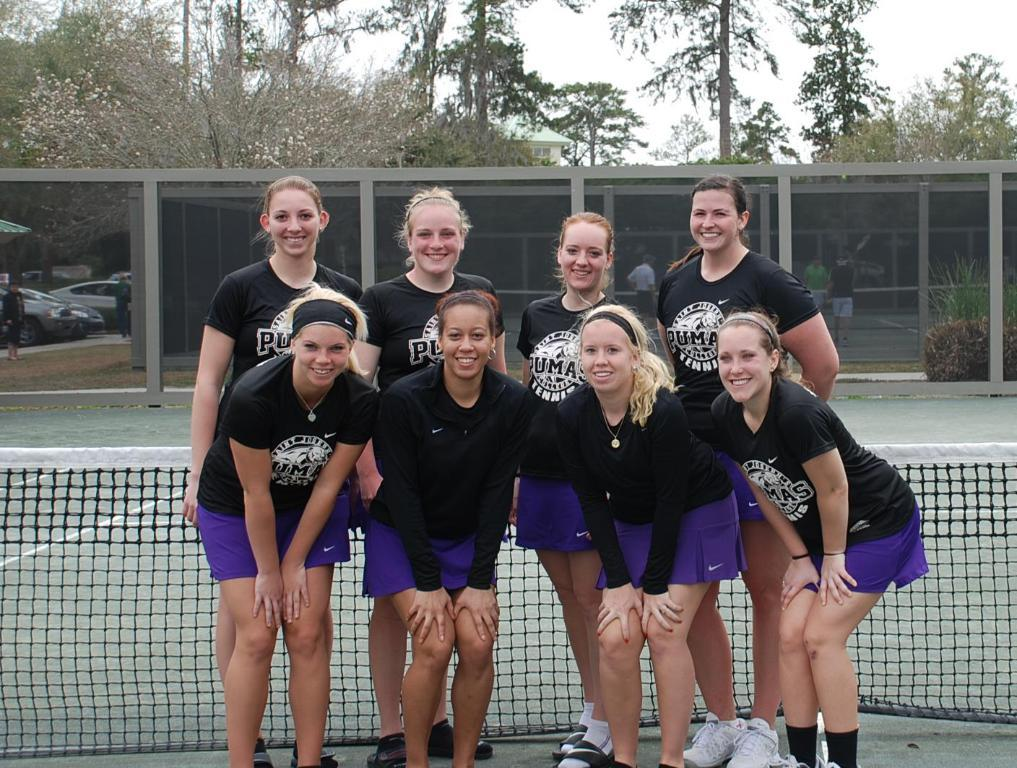<image>
Render a clear and concise summary of the photo. Eight women with shirts that say Pumas are posing for a photo on a tennis court. 